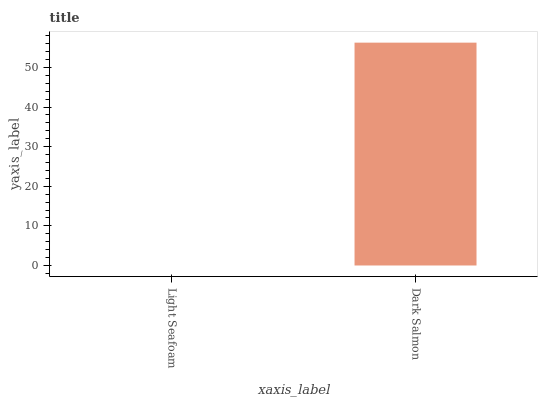Is Light Seafoam the minimum?
Answer yes or no. Yes. Is Dark Salmon the maximum?
Answer yes or no. Yes. Is Dark Salmon the minimum?
Answer yes or no. No. Is Dark Salmon greater than Light Seafoam?
Answer yes or no. Yes. Is Light Seafoam less than Dark Salmon?
Answer yes or no. Yes. Is Light Seafoam greater than Dark Salmon?
Answer yes or no. No. Is Dark Salmon less than Light Seafoam?
Answer yes or no. No. Is Dark Salmon the high median?
Answer yes or no. Yes. Is Light Seafoam the low median?
Answer yes or no. Yes. Is Light Seafoam the high median?
Answer yes or no. No. Is Dark Salmon the low median?
Answer yes or no. No. 